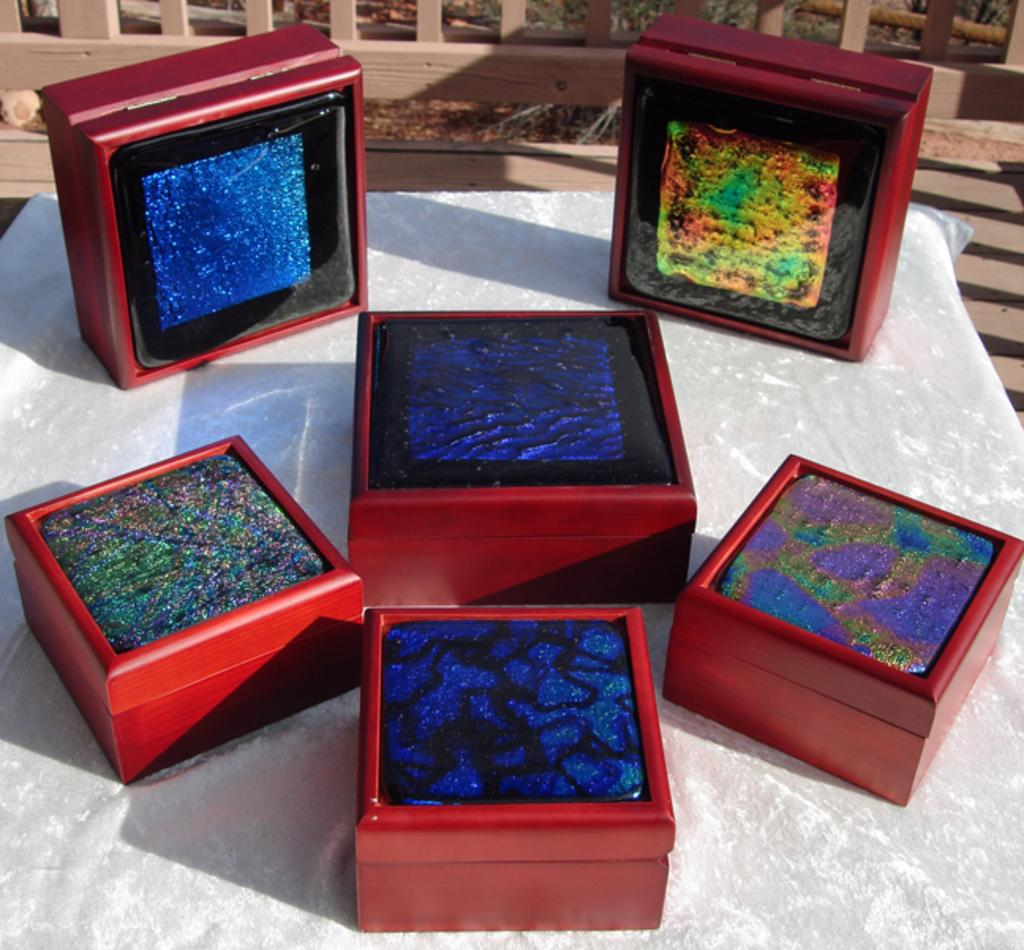What objects are present in the image? There are boxes in the image. Where are the boxes located? The boxes are placed on a white surface. What can be seen on top of the boxes? The boxes have decorations on top of them. What can be seen in the background of the image? There is a wooden fence in the background of the image. What word can be heard being spoken by the boxes in the image? There are no words spoken by the boxes in the image, as they are inanimate objects. 